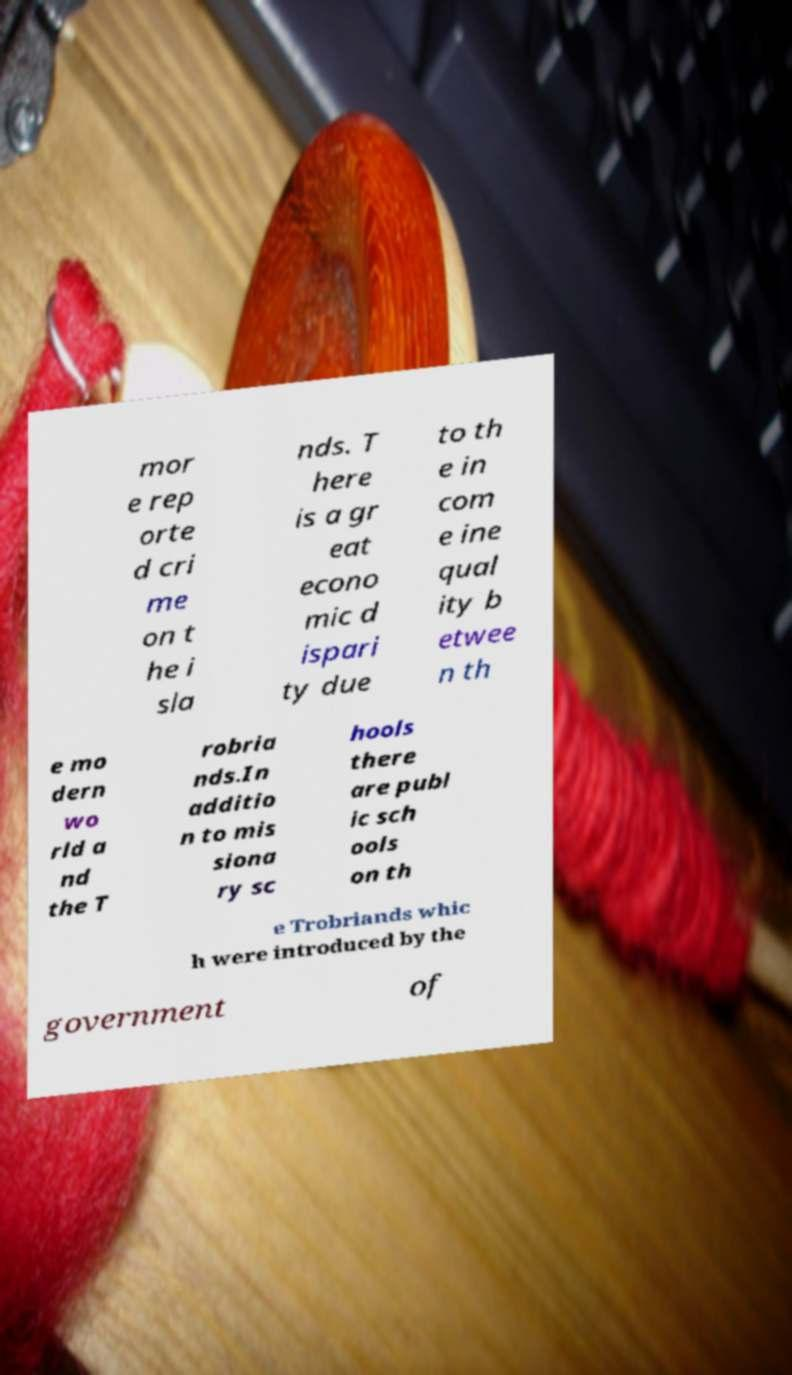There's text embedded in this image that I need extracted. Can you transcribe it verbatim? mor e rep orte d cri me on t he i sla nds. T here is a gr eat econo mic d ispari ty due to th e in com e ine qual ity b etwee n th e mo dern wo rld a nd the T robria nds.In additio n to mis siona ry sc hools there are publ ic sch ools on th e Trobriands whic h were introduced by the government of 